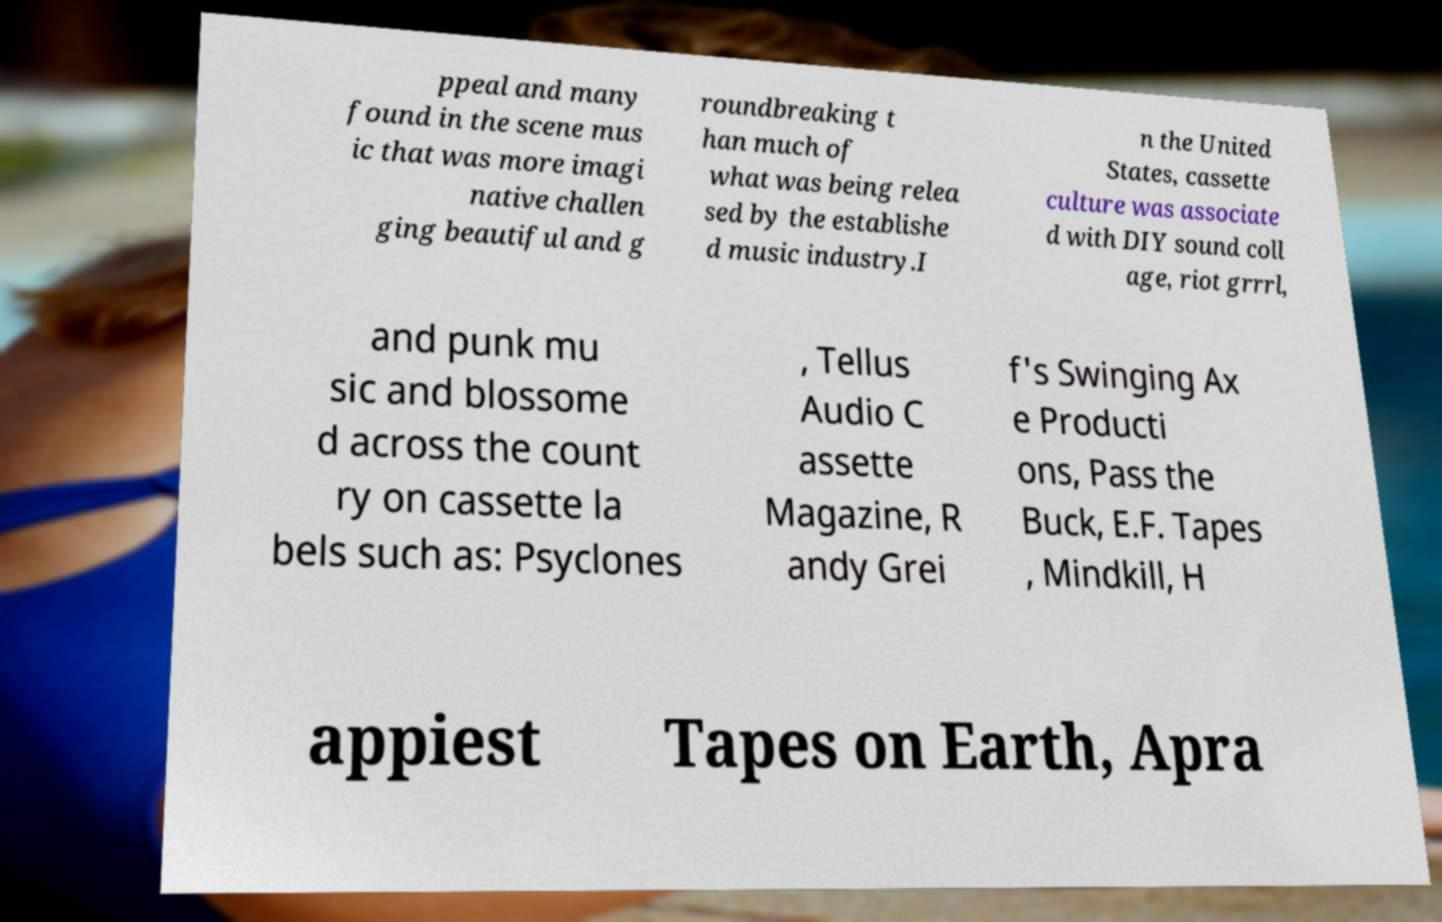What messages or text are displayed in this image? I need them in a readable, typed format. ppeal and many found in the scene mus ic that was more imagi native challen ging beautiful and g roundbreaking t han much of what was being relea sed by the establishe d music industry.I n the United States, cassette culture was associate d with DIY sound coll age, riot grrrl, and punk mu sic and blossome d across the count ry on cassette la bels such as: Psyclones , Tellus Audio C assette Magazine, R andy Grei f's Swinging Ax e Producti ons, Pass the Buck, E.F. Tapes , Mindkill, H appiest Tapes on Earth, Apra 